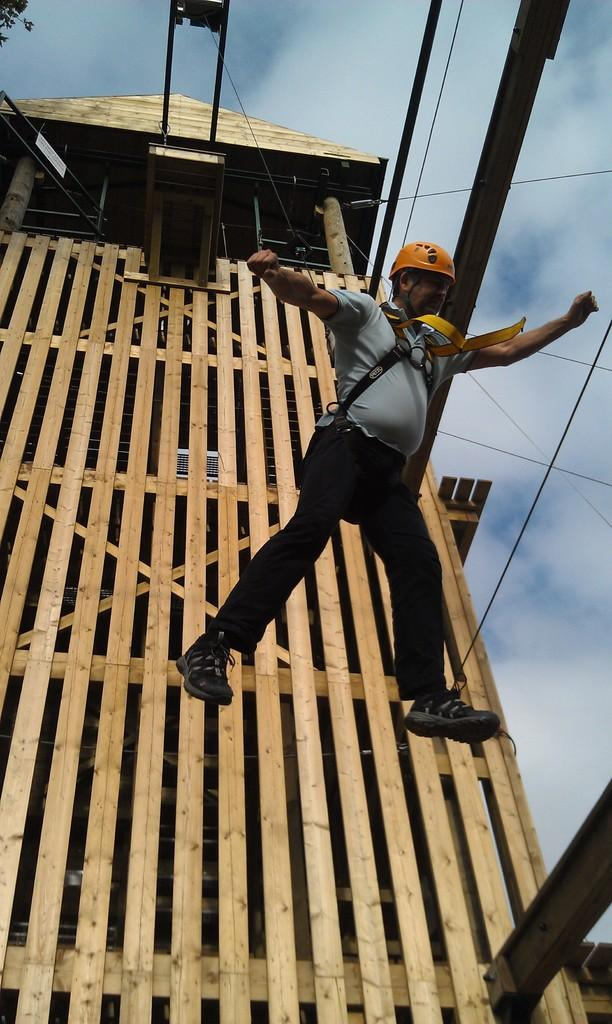What is the person in the image doing? The person is in the air, attached to a rope. How is the person suspended in the air? The person is attached to a rope. What can be seen in the background of the image? There is a wooden fence wall in the background. What letter is written on the wall in the image? There is no letter written on the wall in the image; it is a wooden fence wall. Is there a maid present in the image? There is no mention of a maid in the provided facts, and therefore no such person can be observed in the image. 